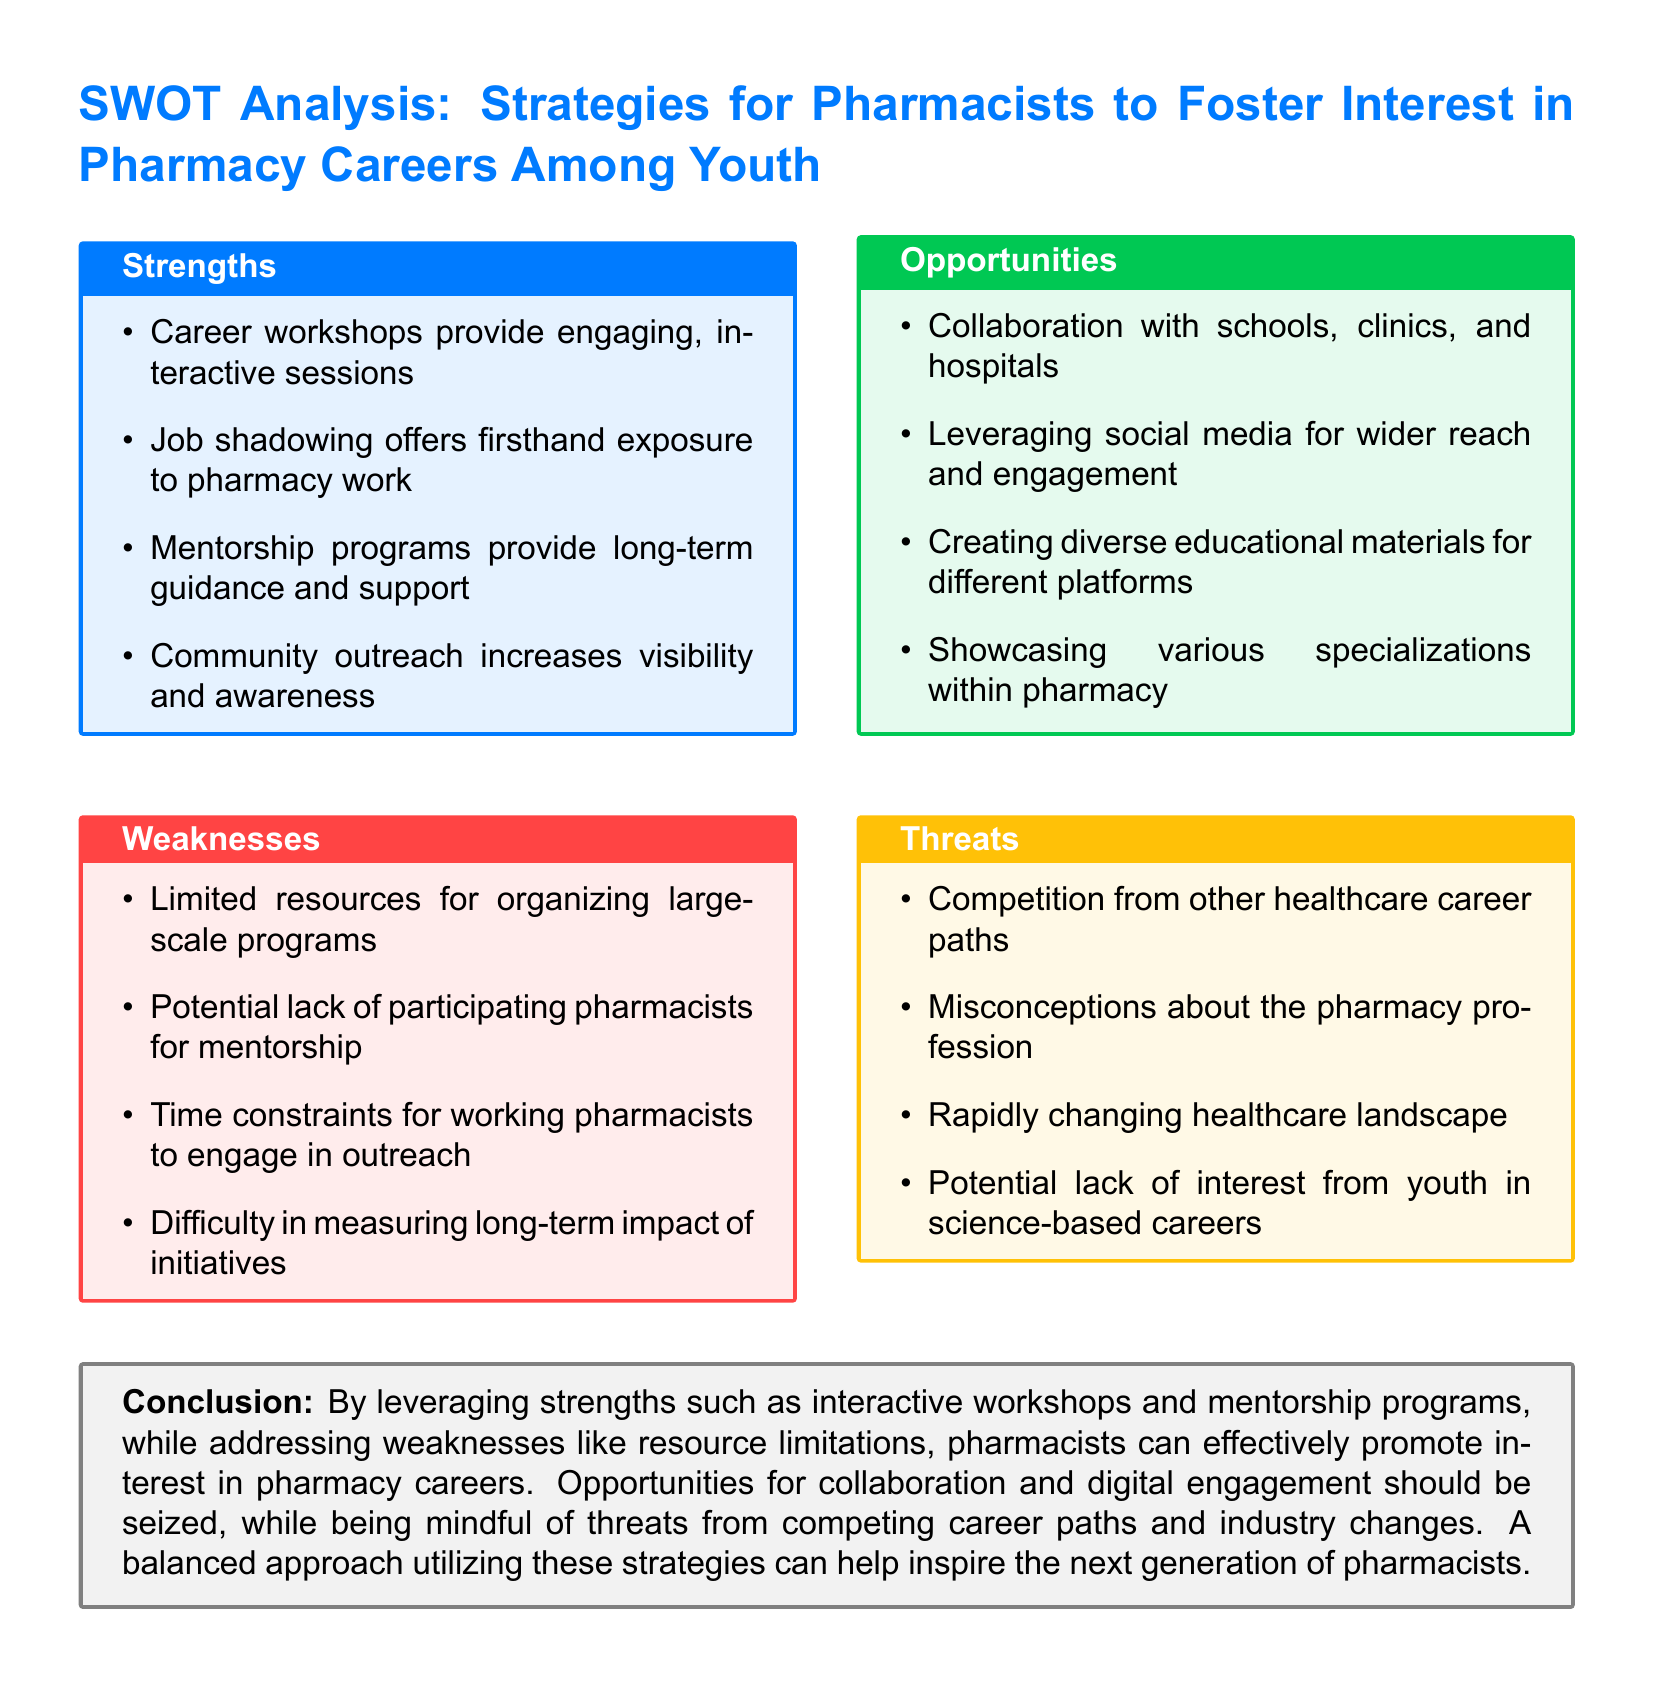What is one strength listed for fostering interest in pharmacy careers? The document lists career workshops providing engaging, interactive sessions as a strength.
Answer: Career workshops What is one weakness identified in the SWOT analysis? The document mentions limited resources for organizing large-scale programs as a weakness.
Answer: Limited resources What is one opportunity for pharmacists to engage with youth? The document states collaboration with schools, clinics, and hospitals as an opportunity.
Answer: Collaboration with schools What is one threat facing pharmacy careers according to the analysis? The document highlights competition from other healthcare career paths as a threat.
Answer: Competition How many strengths are listed in the SWOT analysis? The document enumerates four strengths in the strengths section.
Answer: Four What color is used for the Opportunities section? The document specifies green as the color for the Opportunities section.
Answer: Green What type of programs provide long-term guidance for youth? Mentorship programs are described as providing long-term guidance and support.
Answer: Mentorship programs Which professions do pharmacists have to compete with for youth interest? The document indicates competition from other healthcare career paths.
Answer: Other healthcare career paths What aspect does the conclusion suggest pharmacists utilize to inspire youth? The conclusion emphasizes a balanced approach utilizing strengths and opportunities.
Answer: Balanced approach 